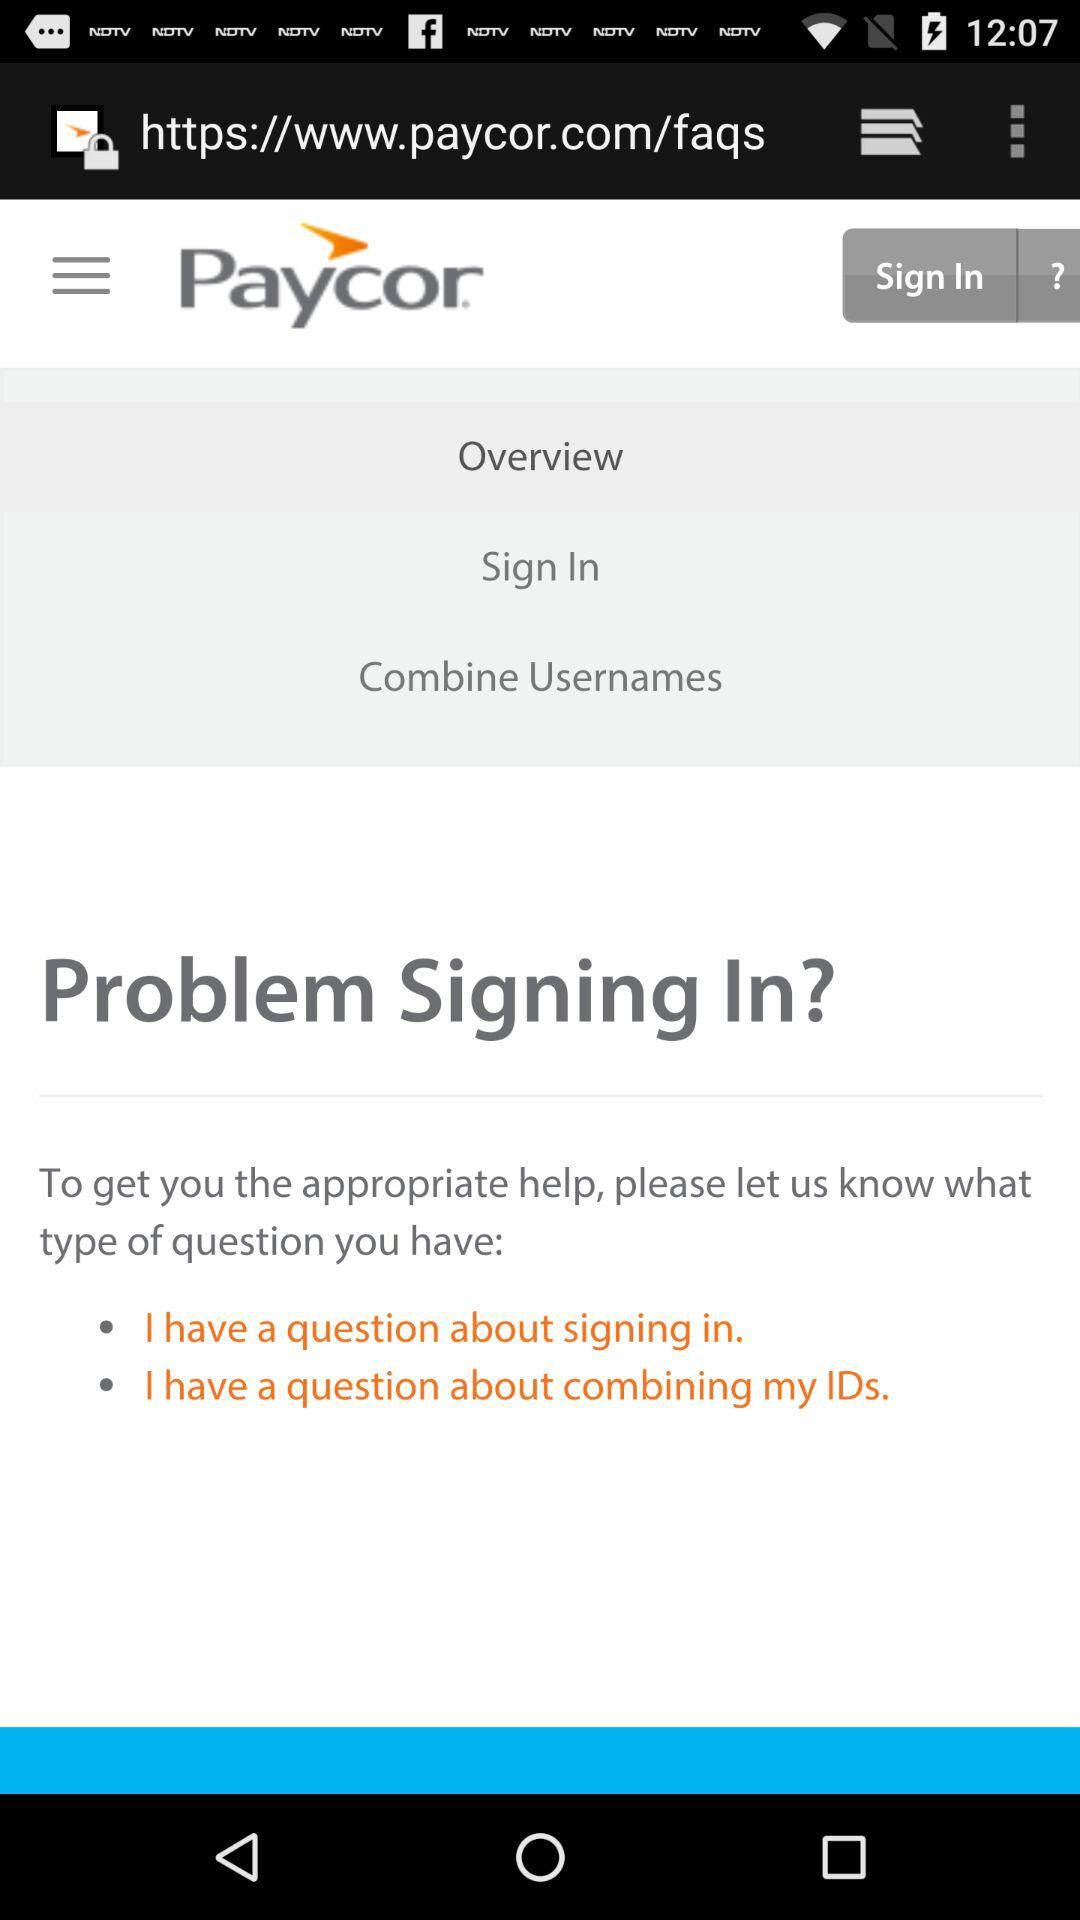How many options are there for what type of question I have?
Answer the question using a single word or phrase. 2 